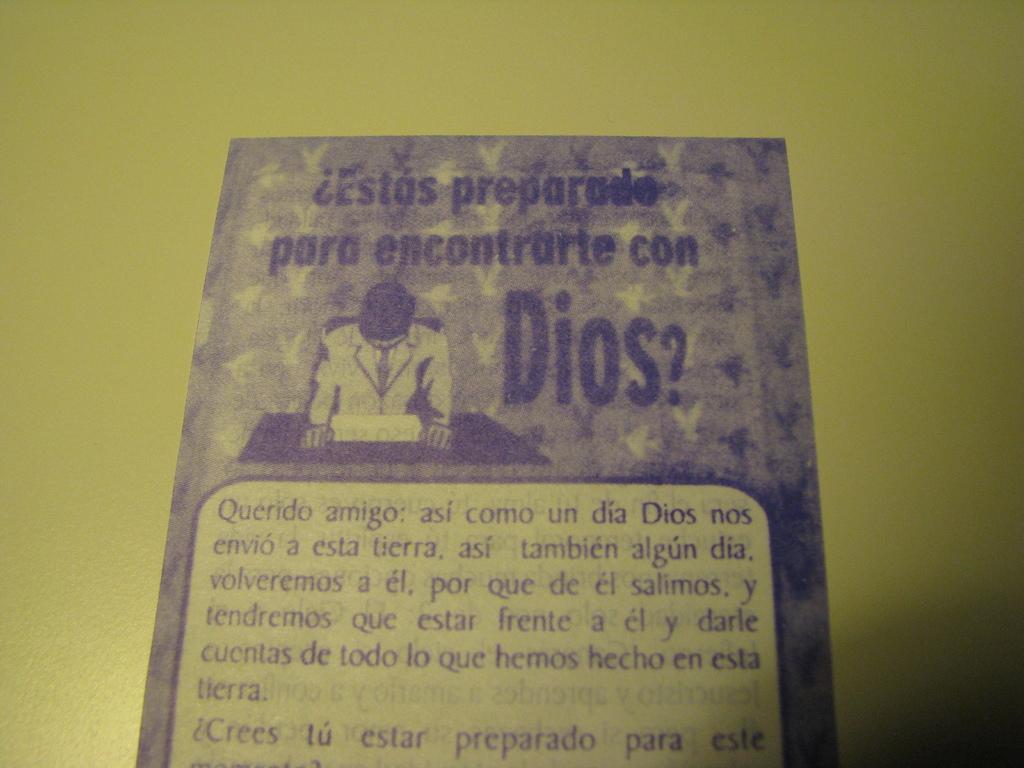What language is this in?
Your response must be concise. Unanswerable. 